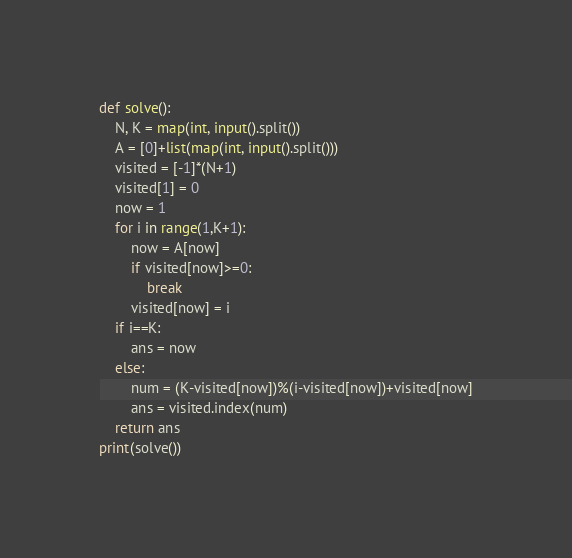Convert code to text. <code><loc_0><loc_0><loc_500><loc_500><_Cython_>def solve():
    N, K = map(int, input().split())
    A = [0]+list(map(int, input().split()))
    visited = [-1]*(N+1)
    visited[1] = 0
    now = 1
    for i in range(1,K+1):
        now = A[now]
        if visited[now]>=0:
            break
        visited[now] = i
    if i==K:
        ans = now
    else:
        num = (K-visited[now])%(i-visited[now])+visited[now]
        ans = visited.index(num)
    return ans
print(solve())
</code> 